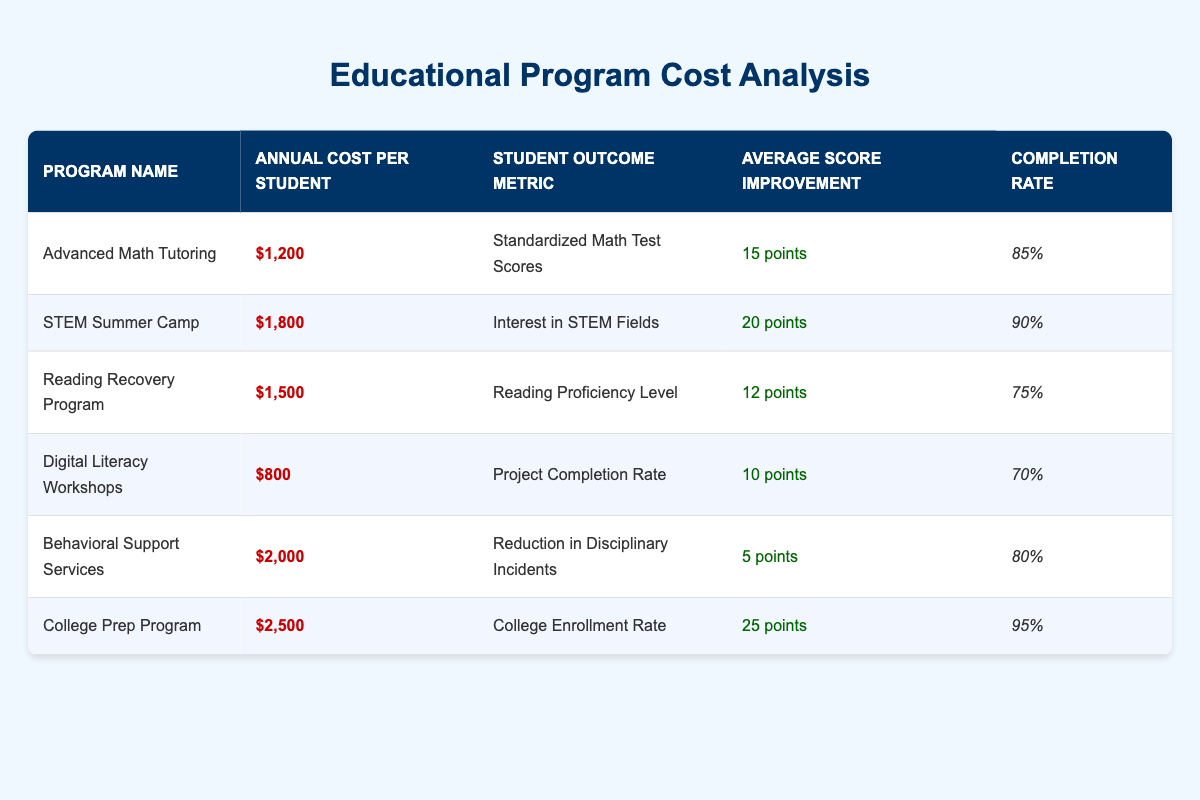What is the annual cost per student for the Digital Literacy Workshops? The table shows that the annual cost per student for the Digital Literacy Workshops is $800.
Answer: $800 Which program has the highest average score improvement? By comparing the "Average Score Improvement" values in the table, the College Prep Program with an average score improvement of 25 points has the highest value.
Answer: College Prep Program What is the completion rate for the Reading Recovery Program? From the table, the completion rate for the Reading Recovery Program is 75%.
Answer: 75% Calculate the average annual cost per student of all programs listed in the table. First, sum the annual costs: 1200 + 1800 + 1500 + 800 + 2000 + 2500 = 10800. There are six programs, so the average is 10800 divided by 6, which equals 1800.
Answer: 1800 Is the average score improvement of the STEM Summer Camp greater than that of the Digital Literacy Workshops? The average score improvement for the STEM Summer Camp is 20 points, while for the Digital Literacy Workshops, it is 10 points. Since 20 is greater than 10, the statement is true.
Answer: Yes Which program has the lowest completion rate, and what is that rate? By looking at the completion rates in the table, the Digital Literacy Workshops have the lowest completion rate of 70%.
Answer: Digital Literacy Workshops, 70% How much more expensive is the College Prep Program compared to the Advanced Math Tutoring program? The College Prep Program costs $2500, while the Advanced Math Tutoring program costs $1200. The difference is $2500 - $1200 = $1300.
Answer: $1300 If we consider only the programs with a completion rate of 80% or above, what is the average annual cost per student for those programs? The qualifying programs are Advanced Math Tutoring, STEM Summer Camp, Behavioral Support Services, and College Prep Program. Their costs are $1200, $1800, $2000, and $2500 respectively, summing to $7500. The average for these four programs is $7500 divided by 4, which equals $1875.
Answer: 1875 